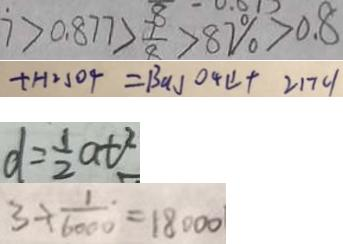Convert formula to latex. <formula><loc_0><loc_0><loc_500><loc_500>7 > 0 . 8 7 7 > \frac { 7 } { 8 } > 8 7 \% > 0 . 8 
 + H _ { 2 } S O _ { 4 } = B a J O _ { 4 } \downarrow + 2 1 7 c \vert 
 d = \frac { 1 } { 2 } a t ^ { 2 } 
 3 \div \frac { 1 } { 6 0 0 0 } = 1 8 0 0 0</formula> 